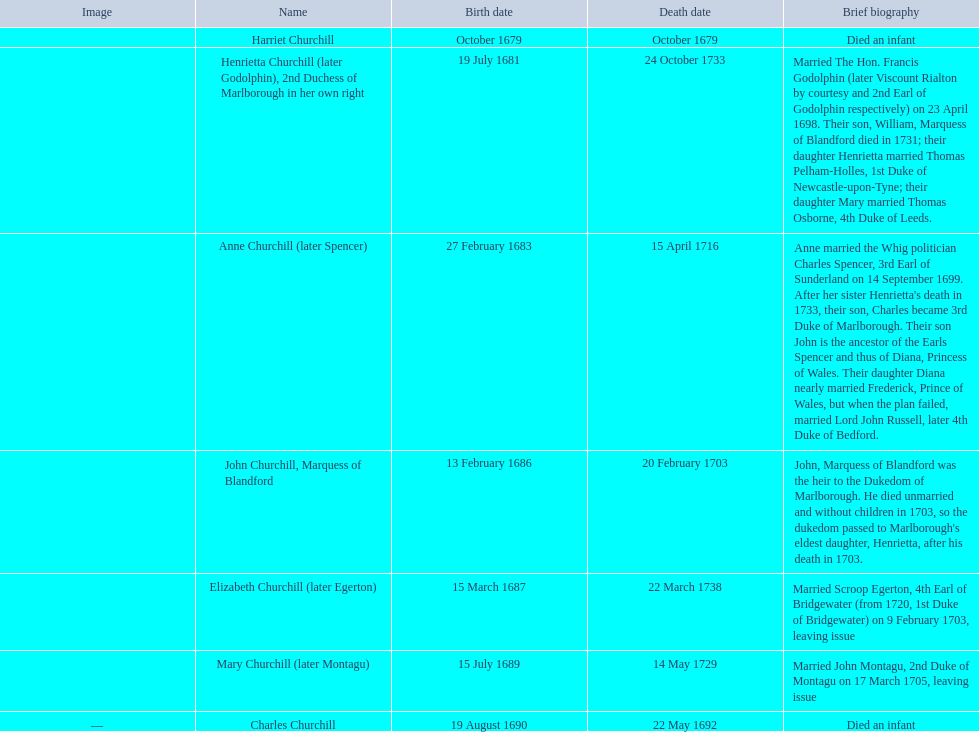What was the number of children born in february? 2. 